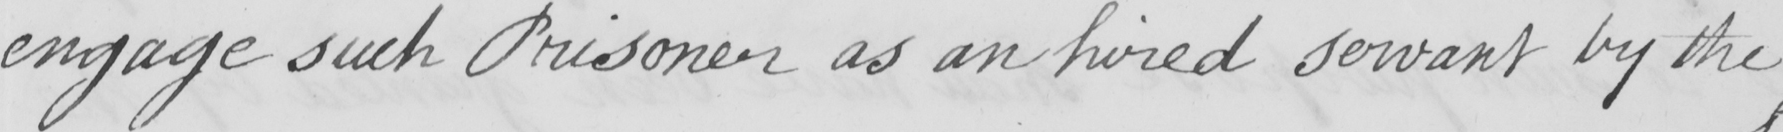Can you tell me what this handwritten text says? engage such Prisoner as an hired servant by the 